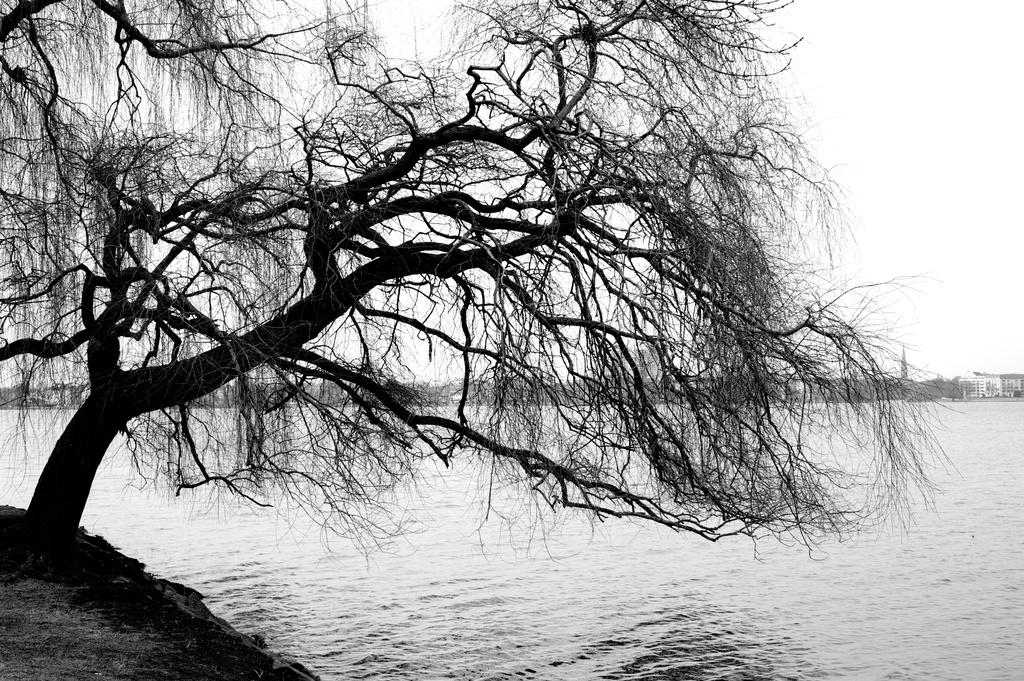What type of vegetation can be seen in the image? There are dried trees in the image. What else is visible besides the trees? There is water, buildings, and the sky visible in the image. What is the color scheme of the image? The image is in black and white. What type of pen is being used to write in the image? There is no pen or writing present in the image. Can you see any smoke coming from the buildings in the image? There is no smoke visible in the image. 